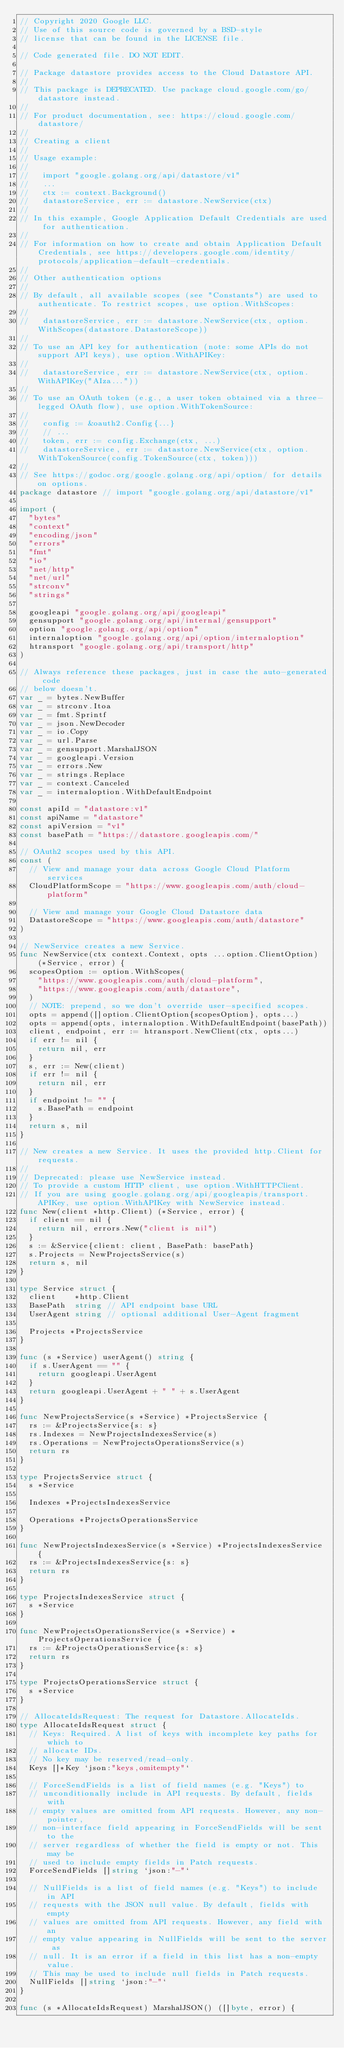Convert code to text. <code><loc_0><loc_0><loc_500><loc_500><_Go_>// Copyright 2020 Google LLC.
// Use of this source code is governed by a BSD-style
// license that can be found in the LICENSE file.

// Code generated file. DO NOT EDIT.

// Package datastore provides access to the Cloud Datastore API.
//
// This package is DEPRECATED. Use package cloud.google.com/go/datastore instead.
//
// For product documentation, see: https://cloud.google.com/datastore/
//
// Creating a client
//
// Usage example:
//
//   import "google.golang.org/api/datastore/v1"
//   ...
//   ctx := context.Background()
//   datastoreService, err := datastore.NewService(ctx)
//
// In this example, Google Application Default Credentials are used for authentication.
//
// For information on how to create and obtain Application Default Credentials, see https://developers.google.com/identity/protocols/application-default-credentials.
//
// Other authentication options
//
// By default, all available scopes (see "Constants") are used to authenticate. To restrict scopes, use option.WithScopes:
//
//   datastoreService, err := datastore.NewService(ctx, option.WithScopes(datastore.DatastoreScope))
//
// To use an API key for authentication (note: some APIs do not support API keys), use option.WithAPIKey:
//
//   datastoreService, err := datastore.NewService(ctx, option.WithAPIKey("AIza..."))
//
// To use an OAuth token (e.g., a user token obtained via a three-legged OAuth flow), use option.WithTokenSource:
//
//   config := &oauth2.Config{...}
//   // ...
//   token, err := config.Exchange(ctx, ...)
//   datastoreService, err := datastore.NewService(ctx, option.WithTokenSource(config.TokenSource(ctx, token)))
//
// See https://godoc.org/google.golang.org/api/option/ for details on options.
package datastore // import "google.golang.org/api/datastore/v1"

import (
	"bytes"
	"context"
	"encoding/json"
	"errors"
	"fmt"
	"io"
	"net/http"
	"net/url"
	"strconv"
	"strings"

	googleapi "google.golang.org/api/googleapi"
	gensupport "google.golang.org/api/internal/gensupport"
	option "google.golang.org/api/option"
	internaloption "google.golang.org/api/option/internaloption"
	htransport "google.golang.org/api/transport/http"
)

// Always reference these packages, just in case the auto-generated code
// below doesn't.
var _ = bytes.NewBuffer
var _ = strconv.Itoa
var _ = fmt.Sprintf
var _ = json.NewDecoder
var _ = io.Copy
var _ = url.Parse
var _ = gensupport.MarshalJSON
var _ = googleapi.Version
var _ = errors.New
var _ = strings.Replace
var _ = context.Canceled
var _ = internaloption.WithDefaultEndpoint

const apiId = "datastore:v1"
const apiName = "datastore"
const apiVersion = "v1"
const basePath = "https://datastore.googleapis.com/"

// OAuth2 scopes used by this API.
const (
	// View and manage your data across Google Cloud Platform services
	CloudPlatformScope = "https://www.googleapis.com/auth/cloud-platform"

	// View and manage your Google Cloud Datastore data
	DatastoreScope = "https://www.googleapis.com/auth/datastore"
)

// NewService creates a new Service.
func NewService(ctx context.Context, opts ...option.ClientOption) (*Service, error) {
	scopesOption := option.WithScopes(
		"https://www.googleapis.com/auth/cloud-platform",
		"https://www.googleapis.com/auth/datastore",
	)
	// NOTE: prepend, so we don't override user-specified scopes.
	opts = append([]option.ClientOption{scopesOption}, opts...)
	opts = append(opts, internaloption.WithDefaultEndpoint(basePath))
	client, endpoint, err := htransport.NewClient(ctx, opts...)
	if err != nil {
		return nil, err
	}
	s, err := New(client)
	if err != nil {
		return nil, err
	}
	if endpoint != "" {
		s.BasePath = endpoint
	}
	return s, nil
}

// New creates a new Service. It uses the provided http.Client for requests.
//
// Deprecated: please use NewService instead.
// To provide a custom HTTP client, use option.WithHTTPClient.
// If you are using google.golang.org/api/googleapis/transport.APIKey, use option.WithAPIKey with NewService instead.
func New(client *http.Client) (*Service, error) {
	if client == nil {
		return nil, errors.New("client is nil")
	}
	s := &Service{client: client, BasePath: basePath}
	s.Projects = NewProjectsService(s)
	return s, nil
}

type Service struct {
	client    *http.Client
	BasePath  string // API endpoint base URL
	UserAgent string // optional additional User-Agent fragment

	Projects *ProjectsService
}

func (s *Service) userAgent() string {
	if s.UserAgent == "" {
		return googleapi.UserAgent
	}
	return googleapi.UserAgent + " " + s.UserAgent
}

func NewProjectsService(s *Service) *ProjectsService {
	rs := &ProjectsService{s: s}
	rs.Indexes = NewProjectsIndexesService(s)
	rs.Operations = NewProjectsOperationsService(s)
	return rs
}

type ProjectsService struct {
	s *Service

	Indexes *ProjectsIndexesService

	Operations *ProjectsOperationsService
}

func NewProjectsIndexesService(s *Service) *ProjectsIndexesService {
	rs := &ProjectsIndexesService{s: s}
	return rs
}

type ProjectsIndexesService struct {
	s *Service
}

func NewProjectsOperationsService(s *Service) *ProjectsOperationsService {
	rs := &ProjectsOperationsService{s: s}
	return rs
}

type ProjectsOperationsService struct {
	s *Service
}

// AllocateIdsRequest: The request for Datastore.AllocateIds.
type AllocateIdsRequest struct {
	// Keys: Required. A list of keys with incomplete key paths for which to
	// allocate IDs.
	// No key may be reserved/read-only.
	Keys []*Key `json:"keys,omitempty"`

	// ForceSendFields is a list of field names (e.g. "Keys") to
	// unconditionally include in API requests. By default, fields with
	// empty values are omitted from API requests. However, any non-pointer,
	// non-interface field appearing in ForceSendFields will be sent to the
	// server regardless of whether the field is empty or not. This may be
	// used to include empty fields in Patch requests.
	ForceSendFields []string `json:"-"`

	// NullFields is a list of field names (e.g. "Keys") to include in API
	// requests with the JSON null value. By default, fields with empty
	// values are omitted from API requests. However, any field with an
	// empty value appearing in NullFields will be sent to the server as
	// null. It is an error if a field in this list has a non-empty value.
	// This may be used to include null fields in Patch requests.
	NullFields []string `json:"-"`
}

func (s *AllocateIdsRequest) MarshalJSON() ([]byte, error) {</code> 